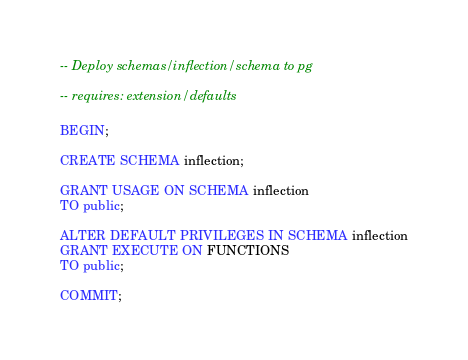<code> <loc_0><loc_0><loc_500><loc_500><_SQL_>-- Deploy schemas/inflection/schema to pg

-- requires: extension/defaults

BEGIN;

CREATE SCHEMA inflection;

GRANT USAGE ON SCHEMA inflection
TO public;

ALTER DEFAULT PRIVILEGES IN SCHEMA inflection
GRANT EXECUTE ON FUNCTIONS
TO public;

COMMIT;
</code> 